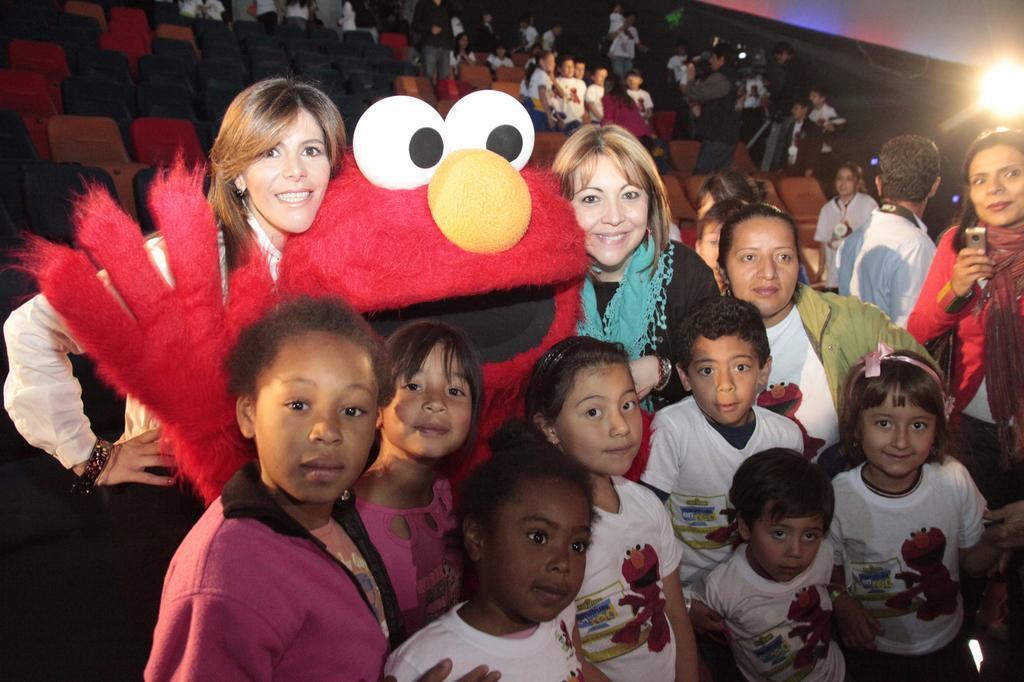Can you describe this image briefly? In this picture there are ladies and children in the center of the image and there are chairs and people in the background area of the image, there is a light in the top right side of the image. 